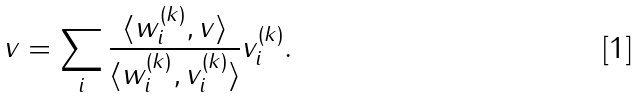<formula> <loc_0><loc_0><loc_500><loc_500>v = \sum _ { i } \frac { \langle w _ { i } ^ { ( k ) } , v \rangle } { \langle w _ { i } ^ { ( k ) } , v _ { i } ^ { ( k ) } \rangle } v _ { i } ^ { ( k ) } .</formula> 